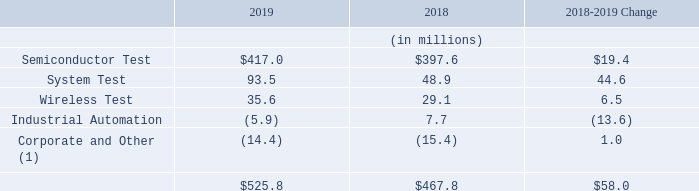Income (Loss) Before Income Taxes
(1) Included in Corporate and Other are the following: contingent consideration adjustments, investment impairment, pension and postretirement plans actuarial (gains) and losses, interest (income) and expense, net foreign exchange (gains) and losses, intercompany eliminations and acquisition related charges.
The increase in income before income taxes in Semiconductor Test from 2018 to 2019 was driven primarily by an increase in semiconductor tester sales for 5G infrastructure and image sensors, partially offset by a decrease in sales in the automotive and analog test segments. The increase in income before income taxes in System Test from 2018 to 2019 was primarily due to higher sales in Storage Test of 3.5” hard disk drive testers, higher sales in Defense/Aerospace test instrumentation and systems, and higher sales in Production Board Test from higher 5G demand. The increase in income before income taxes in Wireless Test from 2018 to 2019 was primarily due to higher demand for millimeter wave and cellular test products driven by new wireless standards and 5G partially offset by lower sales in connectivity test products and services. The decrease in income before income taxes in Industrial Automation from 2018 to 2019 was due primarily to higher sales and marketing, and engineering spending.
What is included in Corporate and Other? Contingent consideration adjustments, investment impairment, pension and postretirement plans actuarial (gains) and losses, interest (income) and expense, net foreign exchange (gains) and losses, intercompany eliminations and acquisition related charges. What was the increase in income before income taxes in Semiconductor Test driven by? By an increase in semiconductor tester sales for 5g infrastructure and image sensors, partially offset by a decrease in sales in the automotive and analog test segments. What are the segments considered under income (loss) before income taxes in the table? Semiconductor test, system test, wireless test, industrial automation, corporate and other. In which year was the amount for Wireless Test the largest? 35.6>29.1
Answer: 2019. What was the percentage change in Wireless Test in 2019 from 2018?
Answer scale should be: percent. (35.6-29.1)/29.1
Answer: 22.34. What was the percentage change in System Test in 2019 from 2018?
Answer scale should be: percent. (93.5-48.9)/48.9
Answer: 91.21. 